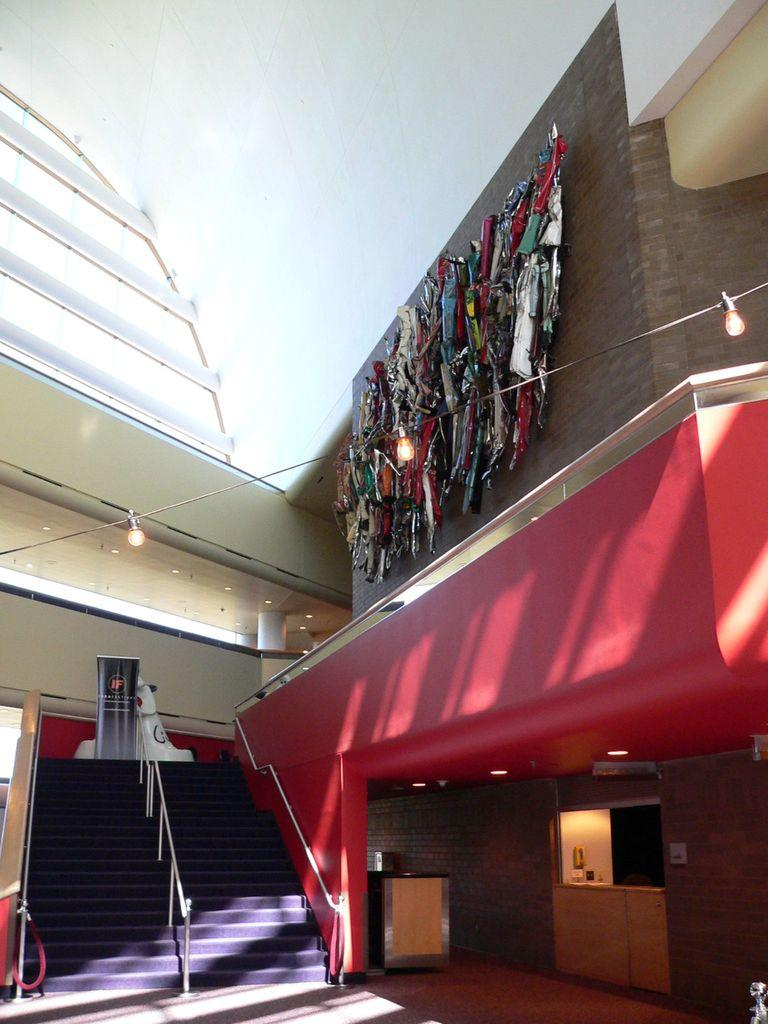What type of structure is present in the image? There are stairs in the image. What can be found on the right side of the image? There is a shop on the right side of the image. What type of furniture is visible in the image? There are cupboards in the image. What is visible at the top of the image? There are lights visible at the top of the image. What type of architectural element is present in the image? There is a wall in the image. What type of leather is used to make the club in the image? There is no club present in the image, and therefore no leather can be associated with it. 